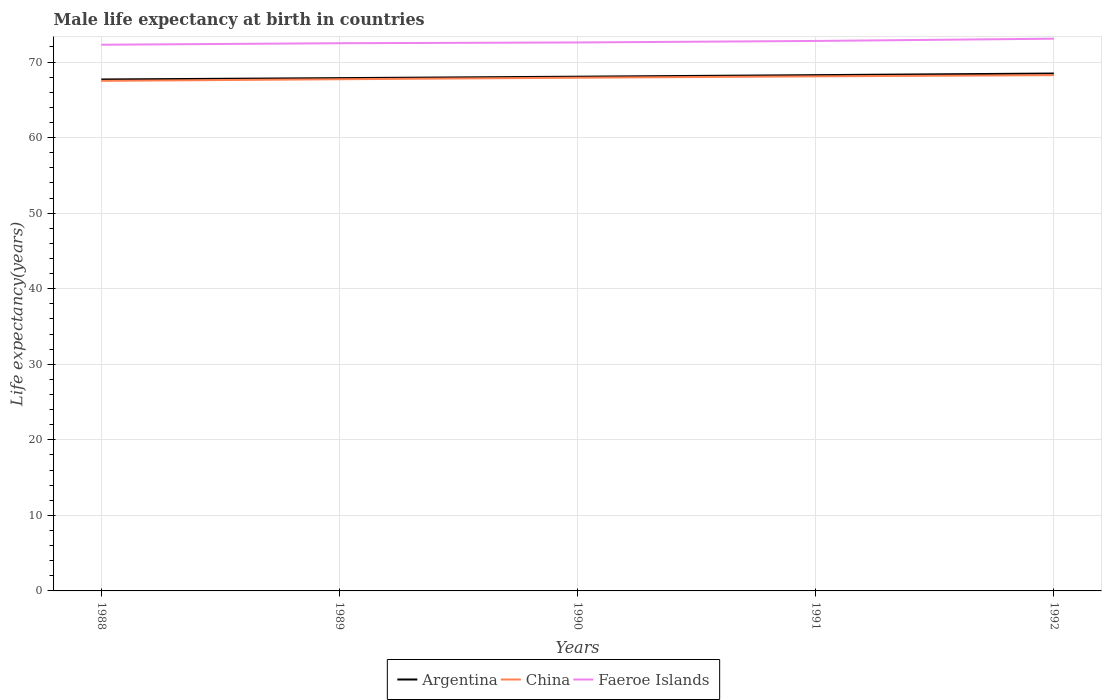Does the line corresponding to Faeroe Islands intersect with the line corresponding to Argentina?
Provide a succinct answer. No. Is the number of lines equal to the number of legend labels?
Your response must be concise. Yes. Across all years, what is the maximum male life expectancy at birth in Faeroe Islands?
Offer a very short reply. 72.3. What is the total male life expectancy at birth in China in the graph?
Offer a terse response. -0.21. What is the difference between the highest and the second highest male life expectancy at birth in China?
Your answer should be compact. 0.75. What is the difference between the highest and the lowest male life expectancy at birth in Faeroe Islands?
Make the answer very short. 2. How many years are there in the graph?
Make the answer very short. 5. Are the values on the major ticks of Y-axis written in scientific E-notation?
Offer a very short reply. No. How many legend labels are there?
Make the answer very short. 3. What is the title of the graph?
Offer a terse response. Male life expectancy at birth in countries. What is the label or title of the X-axis?
Provide a succinct answer. Years. What is the label or title of the Y-axis?
Provide a short and direct response. Life expectancy(years). What is the Life expectancy(years) of Argentina in 1988?
Offer a terse response. 67.7. What is the Life expectancy(years) of China in 1988?
Your response must be concise. 67.52. What is the Life expectancy(years) in Faeroe Islands in 1988?
Your answer should be very brief. 72.3. What is the Life expectancy(years) of Argentina in 1989?
Your answer should be very brief. 67.88. What is the Life expectancy(years) of China in 1989?
Give a very brief answer. 67.73. What is the Life expectancy(years) of Faeroe Islands in 1989?
Ensure brevity in your answer.  72.5. What is the Life expectancy(years) of Argentina in 1990?
Your answer should be compact. 68.07. What is the Life expectancy(years) of China in 1990?
Offer a very short reply. 67.93. What is the Life expectancy(years) of Faeroe Islands in 1990?
Give a very brief answer. 72.6. What is the Life expectancy(years) of Argentina in 1991?
Keep it short and to the point. 68.28. What is the Life expectancy(years) of China in 1991?
Make the answer very short. 68.11. What is the Life expectancy(years) of Faeroe Islands in 1991?
Your response must be concise. 72.8. What is the Life expectancy(years) of Argentina in 1992?
Your answer should be compact. 68.49. What is the Life expectancy(years) of China in 1992?
Provide a succinct answer. 68.27. What is the Life expectancy(years) of Faeroe Islands in 1992?
Offer a terse response. 73.1. Across all years, what is the maximum Life expectancy(years) of Argentina?
Your answer should be compact. 68.49. Across all years, what is the maximum Life expectancy(years) of China?
Offer a terse response. 68.27. Across all years, what is the maximum Life expectancy(years) in Faeroe Islands?
Keep it short and to the point. 73.1. Across all years, what is the minimum Life expectancy(years) of Argentina?
Ensure brevity in your answer.  67.7. Across all years, what is the minimum Life expectancy(years) of China?
Provide a succinct answer. 67.52. Across all years, what is the minimum Life expectancy(years) in Faeroe Islands?
Make the answer very short. 72.3. What is the total Life expectancy(years) in Argentina in the graph?
Your answer should be compact. 340.41. What is the total Life expectancy(years) of China in the graph?
Make the answer very short. 339.57. What is the total Life expectancy(years) of Faeroe Islands in the graph?
Give a very brief answer. 363.3. What is the difference between the Life expectancy(years) in Argentina in 1988 and that in 1989?
Keep it short and to the point. -0.18. What is the difference between the Life expectancy(years) in China in 1988 and that in 1989?
Ensure brevity in your answer.  -0.21. What is the difference between the Life expectancy(years) of Faeroe Islands in 1988 and that in 1989?
Give a very brief answer. -0.2. What is the difference between the Life expectancy(years) of Argentina in 1988 and that in 1990?
Ensure brevity in your answer.  -0.37. What is the difference between the Life expectancy(years) in China in 1988 and that in 1990?
Make the answer very short. -0.42. What is the difference between the Life expectancy(years) in Faeroe Islands in 1988 and that in 1990?
Your answer should be compact. -0.3. What is the difference between the Life expectancy(years) in Argentina in 1988 and that in 1991?
Give a very brief answer. -0.57. What is the difference between the Life expectancy(years) in China in 1988 and that in 1991?
Your answer should be compact. -0.6. What is the difference between the Life expectancy(years) in Argentina in 1988 and that in 1992?
Make the answer very short. -0.79. What is the difference between the Life expectancy(years) of China in 1988 and that in 1992?
Make the answer very short. -0.75. What is the difference between the Life expectancy(years) in Faeroe Islands in 1988 and that in 1992?
Provide a succinct answer. -0.8. What is the difference between the Life expectancy(years) in Argentina in 1989 and that in 1990?
Keep it short and to the point. -0.19. What is the difference between the Life expectancy(years) of China in 1989 and that in 1990?
Give a very brief answer. -0.2. What is the difference between the Life expectancy(years) of Faeroe Islands in 1989 and that in 1990?
Offer a terse response. -0.1. What is the difference between the Life expectancy(years) of Argentina in 1989 and that in 1991?
Offer a very short reply. -0.4. What is the difference between the Life expectancy(years) of China in 1989 and that in 1991?
Ensure brevity in your answer.  -0.38. What is the difference between the Life expectancy(years) of Faeroe Islands in 1989 and that in 1991?
Provide a succinct answer. -0.3. What is the difference between the Life expectancy(years) of Argentina in 1989 and that in 1992?
Make the answer very short. -0.61. What is the difference between the Life expectancy(years) of China in 1989 and that in 1992?
Provide a short and direct response. -0.54. What is the difference between the Life expectancy(years) in Argentina in 1990 and that in 1991?
Make the answer very short. -0.2. What is the difference between the Life expectancy(years) in China in 1990 and that in 1991?
Offer a very short reply. -0.18. What is the difference between the Life expectancy(years) in Argentina in 1990 and that in 1992?
Provide a short and direct response. -0.42. What is the difference between the Life expectancy(years) of China in 1990 and that in 1992?
Give a very brief answer. -0.34. What is the difference between the Life expectancy(years) of Argentina in 1991 and that in 1992?
Offer a very short reply. -0.21. What is the difference between the Life expectancy(years) of China in 1991 and that in 1992?
Your answer should be very brief. -0.16. What is the difference between the Life expectancy(years) in Faeroe Islands in 1991 and that in 1992?
Make the answer very short. -0.3. What is the difference between the Life expectancy(years) in Argentina in 1988 and the Life expectancy(years) in China in 1989?
Provide a short and direct response. -0.03. What is the difference between the Life expectancy(years) of Argentina in 1988 and the Life expectancy(years) of Faeroe Islands in 1989?
Offer a terse response. -4.8. What is the difference between the Life expectancy(years) of China in 1988 and the Life expectancy(years) of Faeroe Islands in 1989?
Ensure brevity in your answer.  -4.98. What is the difference between the Life expectancy(years) of Argentina in 1988 and the Life expectancy(years) of China in 1990?
Make the answer very short. -0.23. What is the difference between the Life expectancy(years) in Argentina in 1988 and the Life expectancy(years) in Faeroe Islands in 1990?
Keep it short and to the point. -4.9. What is the difference between the Life expectancy(years) of China in 1988 and the Life expectancy(years) of Faeroe Islands in 1990?
Your answer should be very brief. -5.08. What is the difference between the Life expectancy(years) in Argentina in 1988 and the Life expectancy(years) in China in 1991?
Provide a succinct answer. -0.41. What is the difference between the Life expectancy(years) in Argentina in 1988 and the Life expectancy(years) in Faeroe Islands in 1991?
Provide a succinct answer. -5.1. What is the difference between the Life expectancy(years) in China in 1988 and the Life expectancy(years) in Faeroe Islands in 1991?
Make the answer very short. -5.28. What is the difference between the Life expectancy(years) in Argentina in 1988 and the Life expectancy(years) in China in 1992?
Keep it short and to the point. -0.57. What is the difference between the Life expectancy(years) of Argentina in 1988 and the Life expectancy(years) of Faeroe Islands in 1992?
Provide a succinct answer. -5.4. What is the difference between the Life expectancy(years) of China in 1988 and the Life expectancy(years) of Faeroe Islands in 1992?
Your response must be concise. -5.58. What is the difference between the Life expectancy(years) of Argentina in 1989 and the Life expectancy(years) of China in 1990?
Give a very brief answer. -0.06. What is the difference between the Life expectancy(years) in Argentina in 1989 and the Life expectancy(years) in Faeroe Islands in 1990?
Offer a very short reply. -4.72. What is the difference between the Life expectancy(years) of China in 1989 and the Life expectancy(years) of Faeroe Islands in 1990?
Make the answer very short. -4.87. What is the difference between the Life expectancy(years) in Argentina in 1989 and the Life expectancy(years) in China in 1991?
Provide a succinct answer. -0.23. What is the difference between the Life expectancy(years) of Argentina in 1989 and the Life expectancy(years) of Faeroe Islands in 1991?
Provide a succinct answer. -4.92. What is the difference between the Life expectancy(years) in China in 1989 and the Life expectancy(years) in Faeroe Islands in 1991?
Make the answer very short. -5.07. What is the difference between the Life expectancy(years) of Argentina in 1989 and the Life expectancy(years) of China in 1992?
Ensure brevity in your answer.  -0.39. What is the difference between the Life expectancy(years) in Argentina in 1989 and the Life expectancy(years) in Faeroe Islands in 1992?
Provide a short and direct response. -5.22. What is the difference between the Life expectancy(years) in China in 1989 and the Life expectancy(years) in Faeroe Islands in 1992?
Keep it short and to the point. -5.37. What is the difference between the Life expectancy(years) in Argentina in 1990 and the Life expectancy(years) in China in 1991?
Ensure brevity in your answer.  -0.04. What is the difference between the Life expectancy(years) in Argentina in 1990 and the Life expectancy(years) in Faeroe Islands in 1991?
Provide a short and direct response. -4.73. What is the difference between the Life expectancy(years) in China in 1990 and the Life expectancy(years) in Faeroe Islands in 1991?
Offer a terse response. -4.87. What is the difference between the Life expectancy(years) in Argentina in 1990 and the Life expectancy(years) in China in 1992?
Ensure brevity in your answer.  -0.2. What is the difference between the Life expectancy(years) of Argentina in 1990 and the Life expectancy(years) of Faeroe Islands in 1992?
Give a very brief answer. -5.03. What is the difference between the Life expectancy(years) in China in 1990 and the Life expectancy(years) in Faeroe Islands in 1992?
Offer a terse response. -5.17. What is the difference between the Life expectancy(years) of Argentina in 1991 and the Life expectancy(years) of China in 1992?
Provide a short and direct response. 0. What is the difference between the Life expectancy(years) of Argentina in 1991 and the Life expectancy(years) of Faeroe Islands in 1992?
Your answer should be very brief. -4.83. What is the difference between the Life expectancy(years) in China in 1991 and the Life expectancy(years) in Faeroe Islands in 1992?
Provide a succinct answer. -4.99. What is the average Life expectancy(years) of Argentina per year?
Offer a terse response. 68.08. What is the average Life expectancy(years) in China per year?
Provide a succinct answer. 67.91. What is the average Life expectancy(years) in Faeroe Islands per year?
Offer a very short reply. 72.66. In the year 1988, what is the difference between the Life expectancy(years) of Argentina and Life expectancy(years) of China?
Give a very brief answer. 0.18. In the year 1988, what is the difference between the Life expectancy(years) in Argentina and Life expectancy(years) in Faeroe Islands?
Keep it short and to the point. -4.6. In the year 1988, what is the difference between the Life expectancy(years) of China and Life expectancy(years) of Faeroe Islands?
Provide a short and direct response. -4.78. In the year 1989, what is the difference between the Life expectancy(years) in Argentina and Life expectancy(years) in China?
Provide a succinct answer. 0.15. In the year 1989, what is the difference between the Life expectancy(years) in Argentina and Life expectancy(years) in Faeroe Islands?
Your response must be concise. -4.62. In the year 1989, what is the difference between the Life expectancy(years) in China and Life expectancy(years) in Faeroe Islands?
Make the answer very short. -4.77. In the year 1990, what is the difference between the Life expectancy(years) in Argentina and Life expectancy(years) in China?
Give a very brief answer. 0.14. In the year 1990, what is the difference between the Life expectancy(years) of Argentina and Life expectancy(years) of Faeroe Islands?
Keep it short and to the point. -4.53. In the year 1990, what is the difference between the Life expectancy(years) of China and Life expectancy(years) of Faeroe Islands?
Make the answer very short. -4.67. In the year 1991, what is the difference between the Life expectancy(years) in Argentina and Life expectancy(years) in China?
Offer a terse response. 0.16. In the year 1991, what is the difference between the Life expectancy(years) of Argentina and Life expectancy(years) of Faeroe Islands?
Your response must be concise. -4.53. In the year 1991, what is the difference between the Life expectancy(years) of China and Life expectancy(years) of Faeroe Islands?
Provide a succinct answer. -4.69. In the year 1992, what is the difference between the Life expectancy(years) in Argentina and Life expectancy(years) in China?
Keep it short and to the point. 0.21. In the year 1992, what is the difference between the Life expectancy(years) in Argentina and Life expectancy(years) in Faeroe Islands?
Your answer should be very brief. -4.61. In the year 1992, what is the difference between the Life expectancy(years) in China and Life expectancy(years) in Faeroe Islands?
Provide a succinct answer. -4.83. What is the ratio of the Life expectancy(years) of China in 1988 to that in 1989?
Offer a terse response. 1. What is the ratio of the Life expectancy(years) of Argentina in 1988 to that in 1990?
Ensure brevity in your answer.  0.99. What is the ratio of the Life expectancy(years) in Argentina in 1988 to that in 1991?
Your answer should be very brief. 0.99. What is the ratio of the Life expectancy(years) of China in 1988 to that in 1991?
Offer a terse response. 0.99. What is the ratio of the Life expectancy(years) in China in 1988 to that in 1992?
Offer a terse response. 0.99. What is the ratio of the Life expectancy(years) in Argentina in 1989 to that in 1990?
Offer a very short reply. 1. What is the ratio of the Life expectancy(years) of Argentina in 1989 to that in 1991?
Provide a succinct answer. 0.99. What is the ratio of the Life expectancy(years) of Argentina in 1989 to that in 1992?
Your answer should be compact. 0.99. What is the ratio of the Life expectancy(years) of China in 1990 to that in 1991?
Your answer should be compact. 1. What is the ratio of the Life expectancy(years) of Faeroe Islands in 1990 to that in 1992?
Offer a terse response. 0.99. What is the difference between the highest and the second highest Life expectancy(years) in Argentina?
Give a very brief answer. 0.21. What is the difference between the highest and the second highest Life expectancy(years) in China?
Make the answer very short. 0.16. What is the difference between the highest and the lowest Life expectancy(years) of Argentina?
Make the answer very short. 0.79. What is the difference between the highest and the lowest Life expectancy(years) in China?
Your response must be concise. 0.75. What is the difference between the highest and the lowest Life expectancy(years) in Faeroe Islands?
Your answer should be very brief. 0.8. 